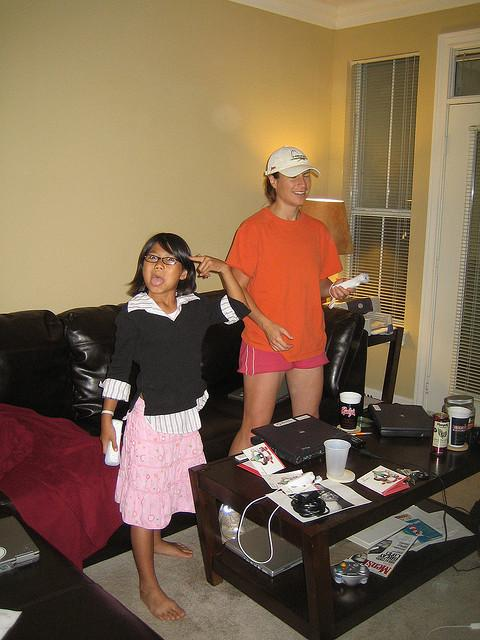What is the girl pointing to? head 